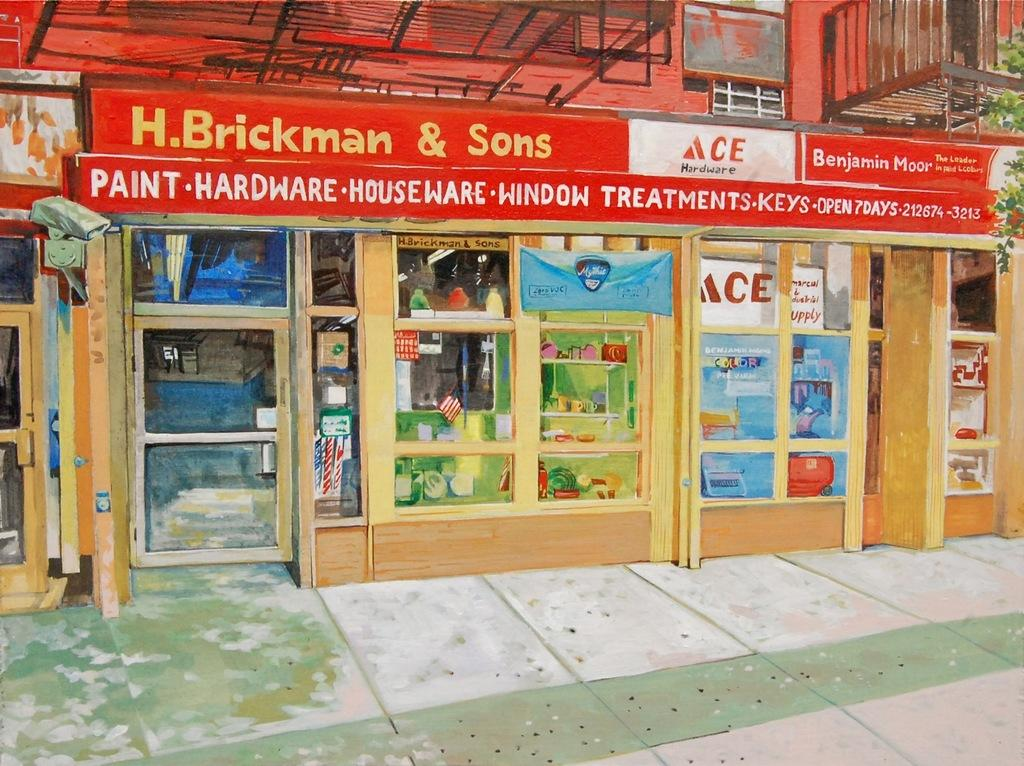<image>
Render a clear and concise summary of the photo. A family owned Ace hardware store during the day time. 